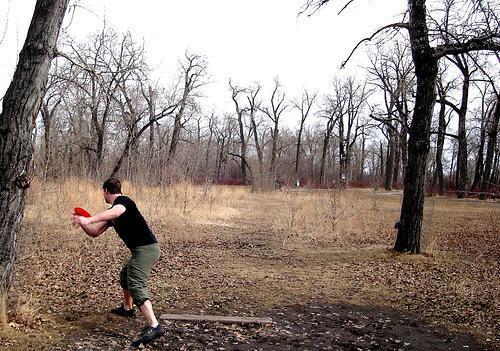How many people are shown?
Give a very brief answer. 1. 